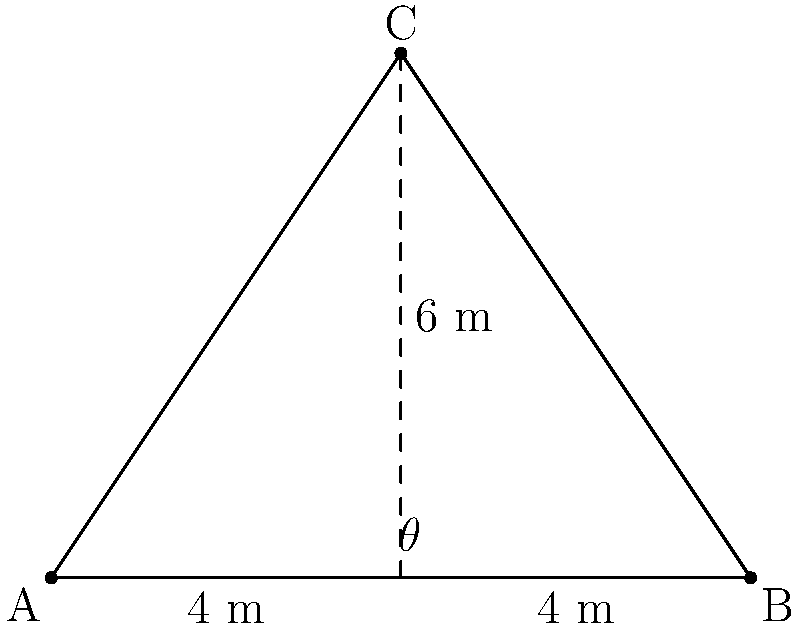As a curator, you're setting up a triangular display area for a new exhibition. The display has a base of 8 meters and a height of 6 meters. You need to determine the optimal viewing angle ($\theta$) from the center of the base to the apex of the triangle for the best visual experience. Using coordinate geometry, calculate this angle in degrees. To solve this problem, we'll use the following steps:

1) First, let's establish our coordinate system. We can place the base of the triangle along the x-axis, with points A(0,0) and B(8,0). The apex of the triangle, point C, will be at (4,6).

2) The center of the base, point D, is at (4,0).

3) We need to find the angle between the line CD and the x-axis. We can do this using the arctangent function.

4) The slope of line CD is:
   $m = \frac{y_C - y_D}{x_C - x_D} = \frac{6 - 0}{4 - 4} = \frac{6}{0}$

5) However, we can't divide by zero. This means the line CD is vertical, and forms a right angle with the x-axis.

6) Therefore, the angle $\theta$ is:
   $\theta = 90°$

7) We can verify this using the Pythagorean theorem:
   $\tan \theta = \frac{\text{opposite}}{\text{adjacent}} = \frac{6}{4} = 1.5$
   $\theta = \arctan(1.5) \approx 56.31°$

8) The complement of this angle (90° - 56.31° = 33.69°) is the angle between CD and the hypotenuse of the right triangle formed by CD and the x-axis.

9) Thus, the angle between CD and the x-axis is indeed 90°.
Answer: $90°$ 